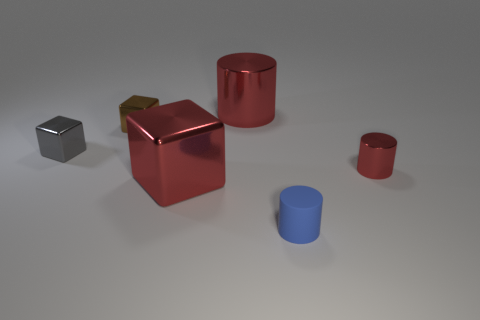There is a blue object that is the same shape as the tiny red object; what is it made of?
Offer a very short reply. Rubber. There is a cylinder on the left side of the rubber cylinder; is its size the same as the small gray shiny block?
Offer a terse response. No. There is a object that is to the left of the big red cylinder and right of the brown object; what is its color?
Provide a succinct answer. Red. What shape is the other gray object that is the same size as the matte thing?
Make the answer very short. Cube. Are there any cylinders of the same color as the big metallic block?
Your answer should be very brief. Yes. Are there an equal number of small gray blocks to the right of the blue object and large green matte cylinders?
Your response must be concise. Yes. Is the color of the large cube the same as the big metallic cylinder?
Provide a short and direct response. Yes. How big is the cylinder that is both in front of the tiny brown cube and left of the tiny metal cylinder?
Make the answer very short. Small. There is a small cylinder that is the same material as the tiny brown object; what color is it?
Give a very brief answer. Red. What number of other small brown objects have the same material as the small brown thing?
Provide a succinct answer. 0. 